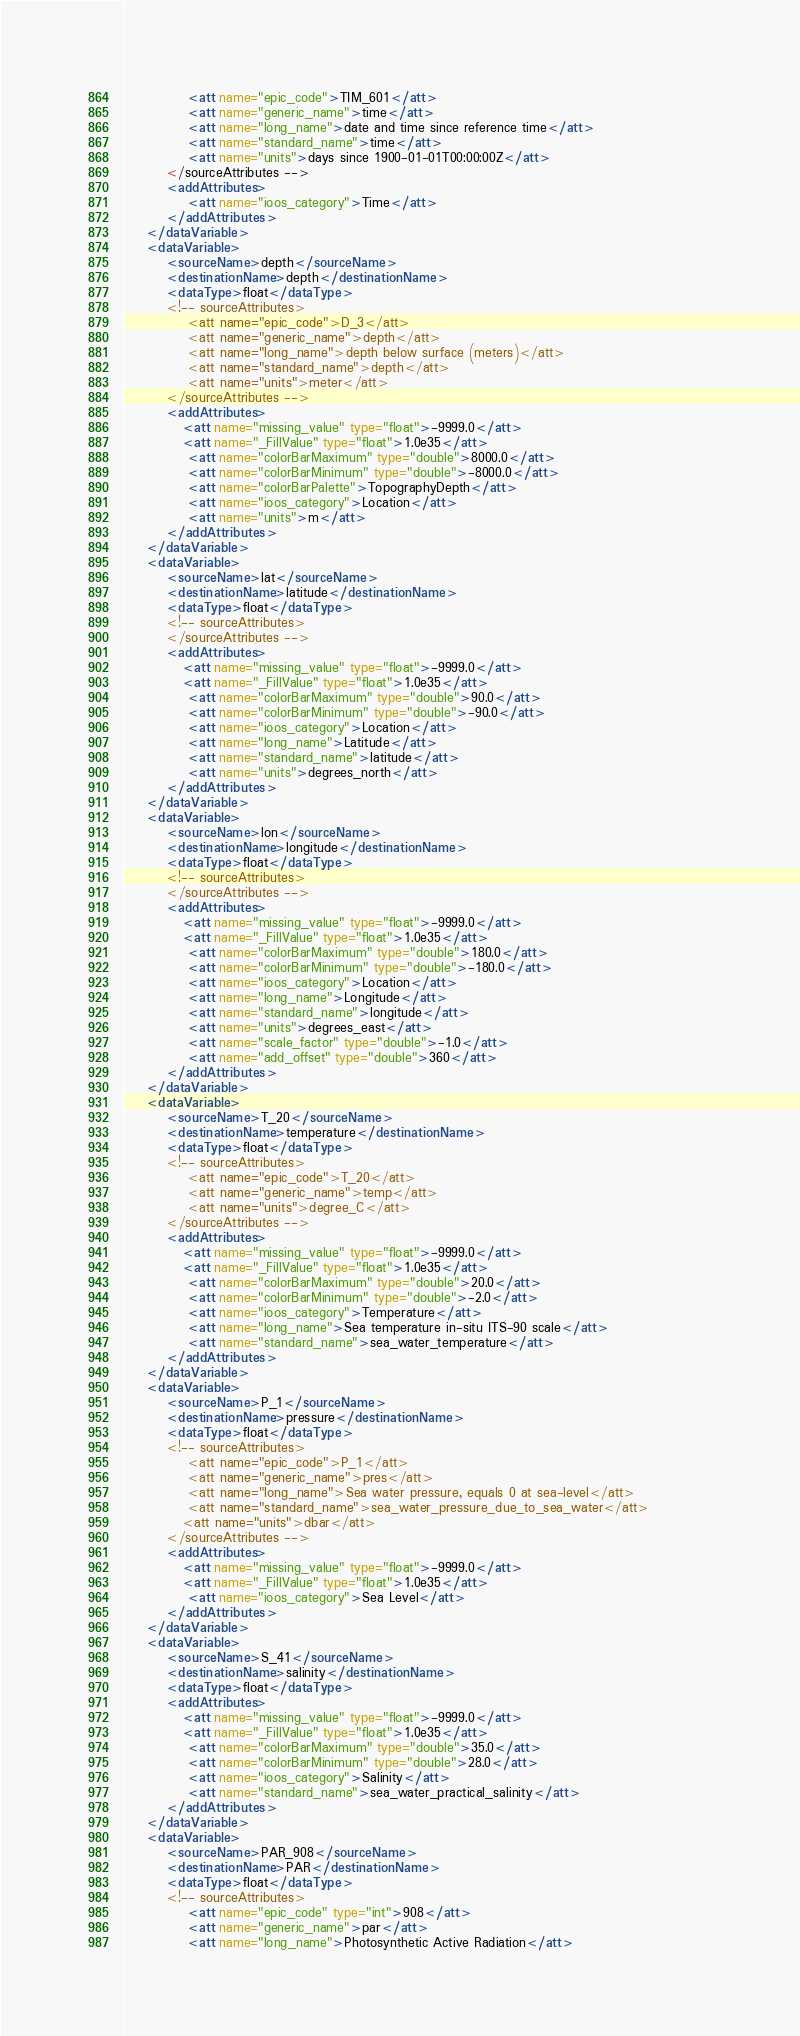Convert code to text. <code><loc_0><loc_0><loc_500><loc_500><_XML_>            <att name="epic_code">TIM_601</att>
            <att name="generic_name">time</att>
            <att name="long_name">date and time since reference time</att>
            <att name="standard_name">time</att>
            <att name="units">days since 1900-01-01T00:00:00Z</att>
        </sourceAttributes -->
        <addAttributes>
            <att name="ioos_category">Time</att>
        </addAttributes>
    </dataVariable>
    <dataVariable>
        <sourceName>depth</sourceName>
        <destinationName>depth</destinationName>
        <dataType>float</dataType>
        <!-- sourceAttributes>
            <att name="epic_code">D_3</att>
            <att name="generic_name">depth</att>
            <att name="long_name">depth below surface (meters)</att>
            <att name="standard_name">depth</att>
            <att name="units">meter</att>
        </sourceAttributes -->
        <addAttributes>
           <att name="missing_value" type="float">-9999.0</att>
           <att name="_FillValue" type="float">1.0e35</att>
            <att name="colorBarMaximum" type="double">8000.0</att>
            <att name="colorBarMinimum" type="double">-8000.0</att>
            <att name="colorBarPalette">TopographyDepth</att>
            <att name="ioos_category">Location</att>
            <att name="units">m</att>
        </addAttributes>
    </dataVariable>
    <dataVariable>
        <sourceName>lat</sourceName>
        <destinationName>latitude</destinationName>
        <dataType>float</dataType>
        <!-- sourceAttributes>
        </sourceAttributes -->
        <addAttributes>
           <att name="missing_value" type="float">-9999.0</att>
           <att name="_FillValue" type="float">1.0e35</att>
            <att name="colorBarMaximum" type="double">90.0</att>
            <att name="colorBarMinimum" type="double">-90.0</att>
            <att name="ioos_category">Location</att>
            <att name="long_name">Latitude</att>
            <att name="standard_name">latitude</att>
            <att name="units">degrees_north</att>
        </addAttributes>
    </dataVariable>
    <dataVariable>
        <sourceName>lon</sourceName>
        <destinationName>longitude</destinationName>
        <dataType>float</dataType>
        <!-- sourceAttributes>
        </sourceAttributes -->
        <addAttributes>
           <att name="missing_value" type="float">-9999.0</att>
           <att name="_FillValue" type="float">1.0e35</att>
            <att name="colorBarMaximum" type="double">180.0</att>
            <att name="colorBarMinimum" type="double">-180.0</att>
            <att name="ioos_category">Location</att>
            <att name="long_name">Longitude</att>
            <att name="standard_name">longitude</att>
            <att name="units">degrees_east</att>
            <att name="scale_factor" type="double">-1.0</att>
            <att name="add_offset" type="double">360</att>
        </addAttributes>
    </dataVariable>
    <dataVariable>
        <sourceName>T_20</sourceName>
        <destinationName>temperature</destinationName>
        <dataType>float</dataType>
        <!-- sourceAttributes>
            <att name="epic_code">T_20</att>
            <att name="generic_name">temp</att>
            <att name="units">degree_C</att>
        </sourceAttributes -->
        <addAttributes>
           <att name="missing_value" type="float">-9999.0</att>
           <att name="_FillValue" type="float">1.0e35</att>
            <att name="colorBarMaximum" type="double">20.0</att>
            <att name="colorBarMinimum" type="double">-2.0</att>
            <att name="ioos_category">Temperature</att>
            <att name="long_name">Sea temperature in-situ ITS-90 scale</att>
            <att name="standard_name">sea_water_temperature</att>
        </addAttributes>
    </dataVariable>
    <dataVariable>
        <sourceName>P_1</sourceName>
        <destinationName>pressure</destinationName>
        <dataType>float</dataType>
        <!-- sourceAttributes>
            <att name="epic_code">P_1</att>
            <att name="generic_name">pres</att>
            <att name="long_name">Sea water pressure, equals 0 at sea-level</att>
            <att name="standard_name">sea_water_pressure_due_to_sea_water</att>            
           <att name="units">dbar</att>
        </sourceAttributes -->
        <addAttributes>
           <att name="missing_value" type="float">-9999.0</att>
           <att name="_FillValue" type="float">1.0e35</att>
            <att name="ioos_category">Sea Level</att>
        </addAttributes>
    </dataVariable>
    <dataVariable>
        <sourceName>S_41</sourceName>
        <destinationName>salinity</destinationName>
        <dataType>float</dataType>
        <addAttributes>
           <att name="missing_value" type="float">-9999.0</att>
           <att name="_FillValue" type="float">1.0e35</att>
            <att name="colorBarMaximum" type="double">35.0</att>
            <att name="colorBarMinimum" type="double">28.0</att>
            <att name="ioos_category">Salinity</att>
            <att name="standard_name">sea_water_practical_salinity</att>
        </addAttributes>
    </dataVariable>
    <dataVariable>
        <sourceName>PAR_908</sourceName>
        <destinationName>PAR</destinationName>
        <dataType>float</dataType>
        <!-- sourceAttributes>
            <att name="epic_code" type="int">908</att>
            <att name="generic_name">par</att>
            <att name="long_name">Photosynthetic Active Radiation</att></code> 